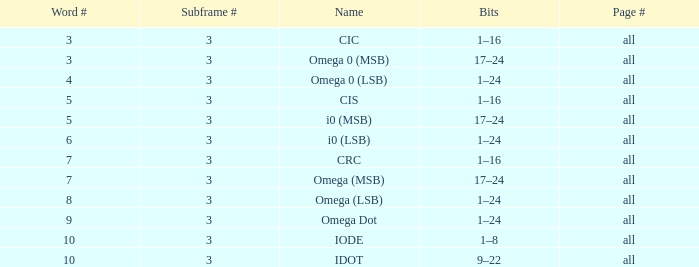What is the total word count with a subframe count greater than 3? None. 